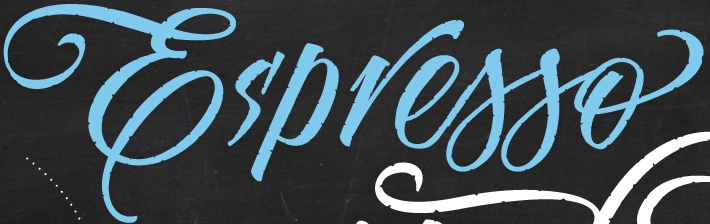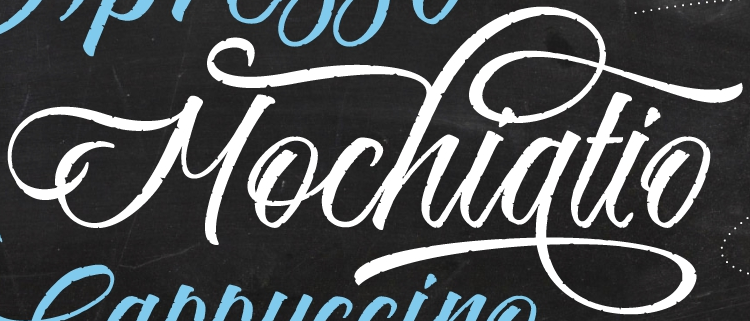Read the text content from these images in order, separated by a semicolon. Es'presso; Mochiatio 